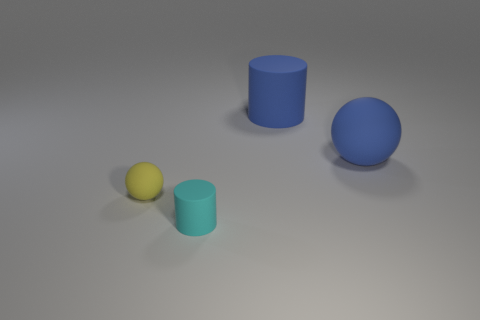The rubber thing that is the same color as the big cylinder is what size?
Your answer should be very brief. Large. Do the big rubber cylinder and the ball that is to the right of the small cyan matte thing have the same color?
Keep it short and to the point. Yes. There is a small matte sphere; are there any large cylinders to the right of it?
Offer a terse response. Yes. There is a matte ball that is on the left side of the small cyan object; is it the same size as the cylinder in front of the big sphere?
Ensure brevity in your answer.  Yes. Are there any blue cylinders that have the same size as the blue ball?
Offer a very short reply. Yes. Is the shape of the thing in front of the yellow ball the same as  the yellow matte object?
Ensure brevity in your answer.  No. The small thing that is in front of the tiny yellow sphere on the left side of the large blue cylinder is what shape?
Ensure brevity in your answer.  Cylinder. Is the shape of the cyan rubber object the same as the yellow object that is in front of the large ball?
Provide a short and direct response. No. There is a large object right of the large blue matte cylinder; how many matte things are in front of it?
Offer a very short reply. 2. There is a big blue thing that is the same shape as the small cyan object; what is it made of?
Make the answer very short. Rubber. 